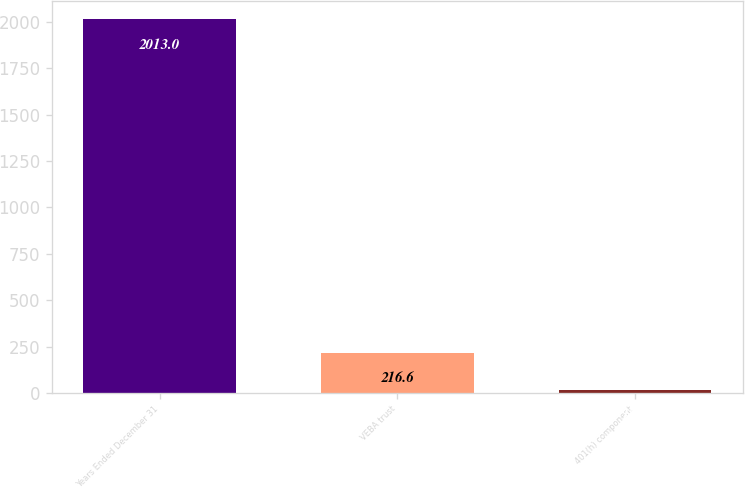<chart> <loc_0><loc_0><loc_500><loc_500><bar_chart><fcel>Years Ended December 31<fcel>VEBA trust<fcel>401(h) component<nl><fcel>2013<fcel>216.6<fcel>17<nl></chart> 